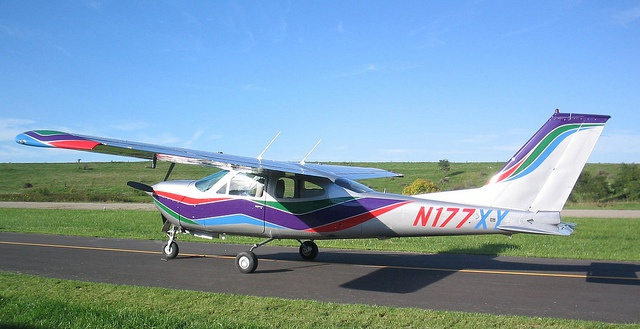Describe the objects in this image and their specific colors. I can see a airplane in gray, white, black, and darkgray tones in this image. 